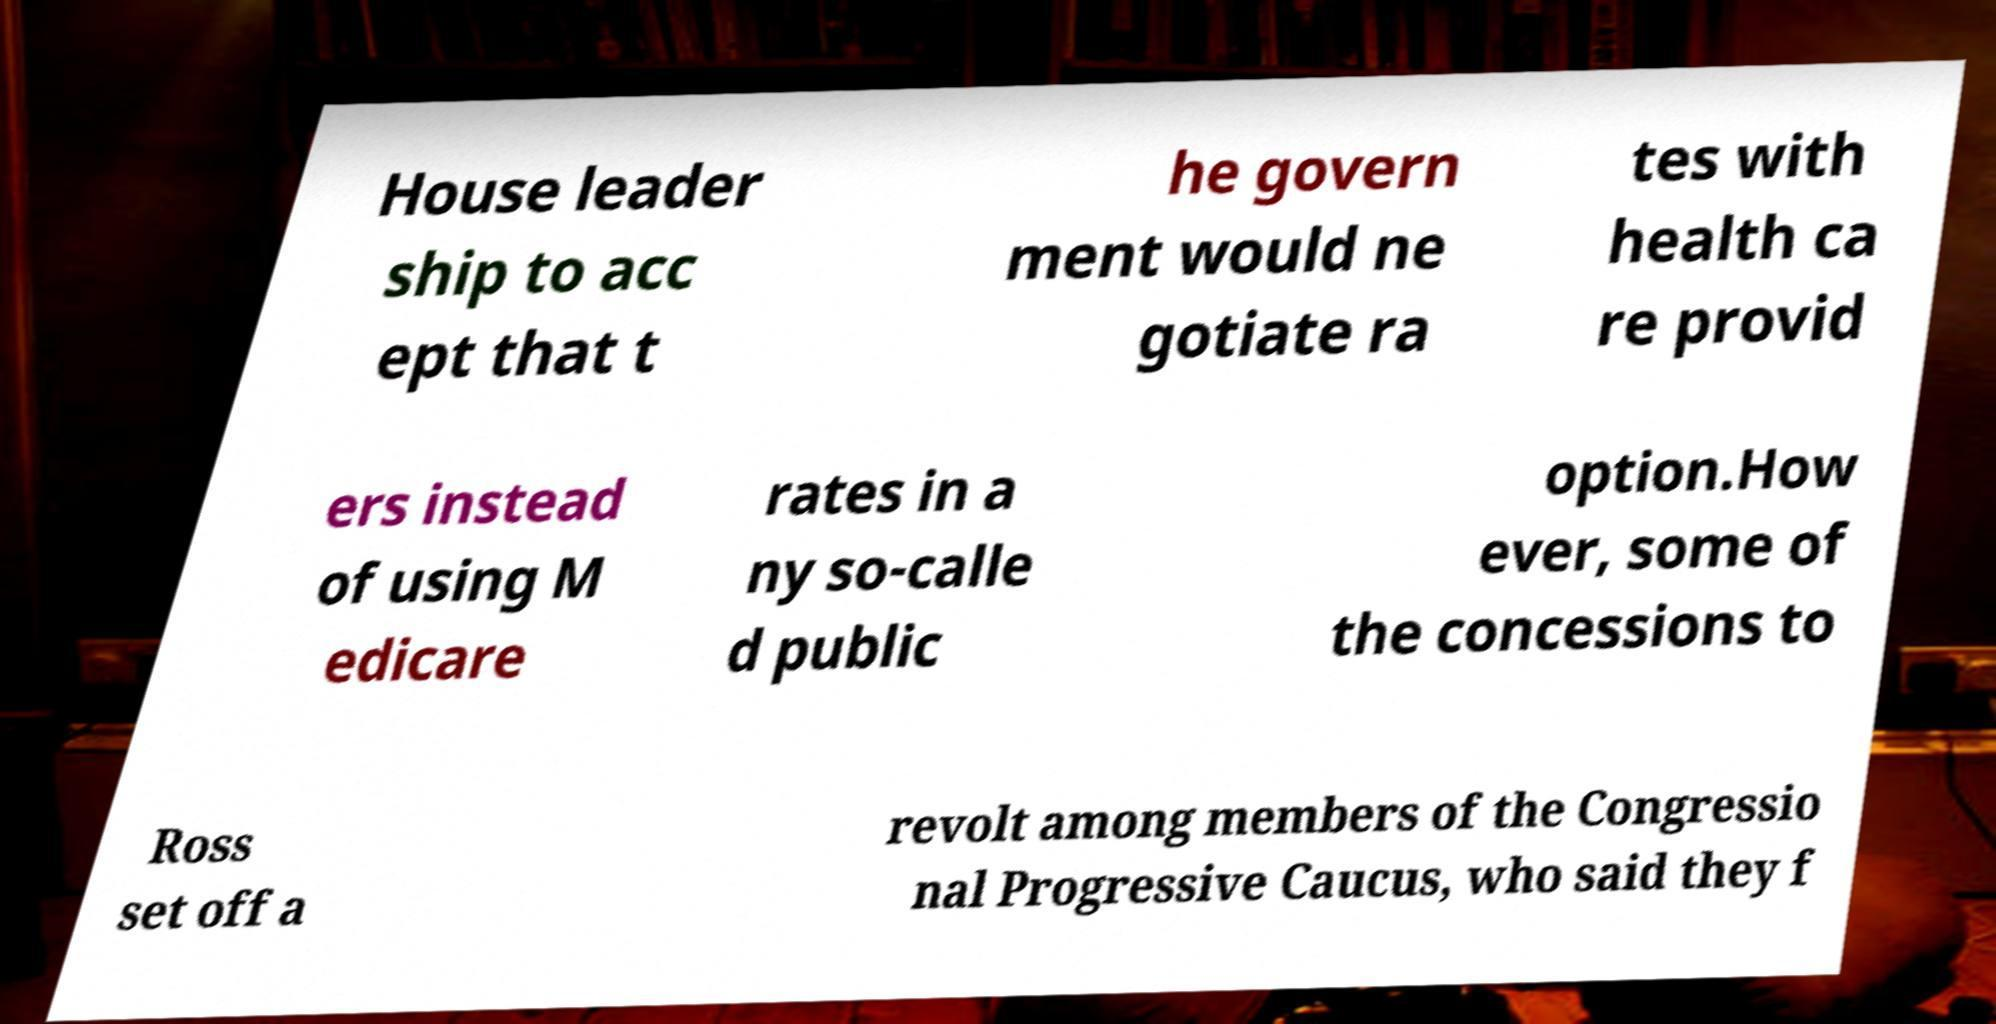There's text embedded in this image that I need extracted. Can you transcribe it verbatim? House leader ship to acc ept that t he govern ment would ne gotiate ra tes with health ca re provid ers instead of using M edicare rates in a ny so-calle d public option.How ever, some of the concessions to Ross set off a revolt among members of the Congressio nal Progressive Caucus, who said they f 